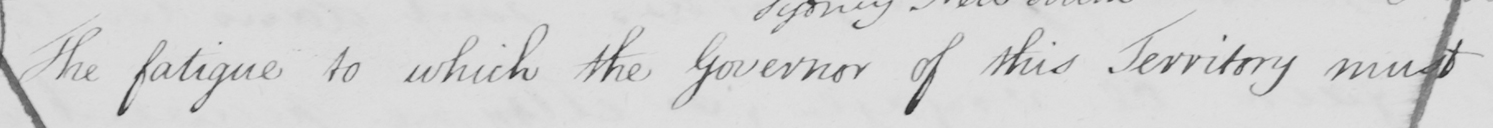Please transcribe the handwritten text in this image. The fatigue to which the Governor of this territory must 